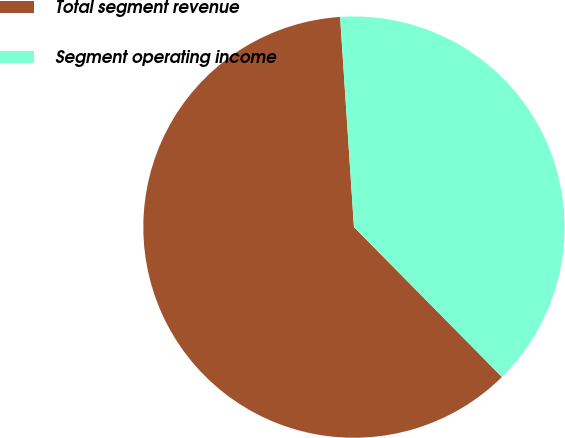Convert chart to OTSL. <chart><loc_0><loc_0><loc_500><loc_500><pie_chart><fcel>Total segment revenue<fcel>Segment operating income<nl><fcel>61.35%<fcel>38.65%<nl></chart> 